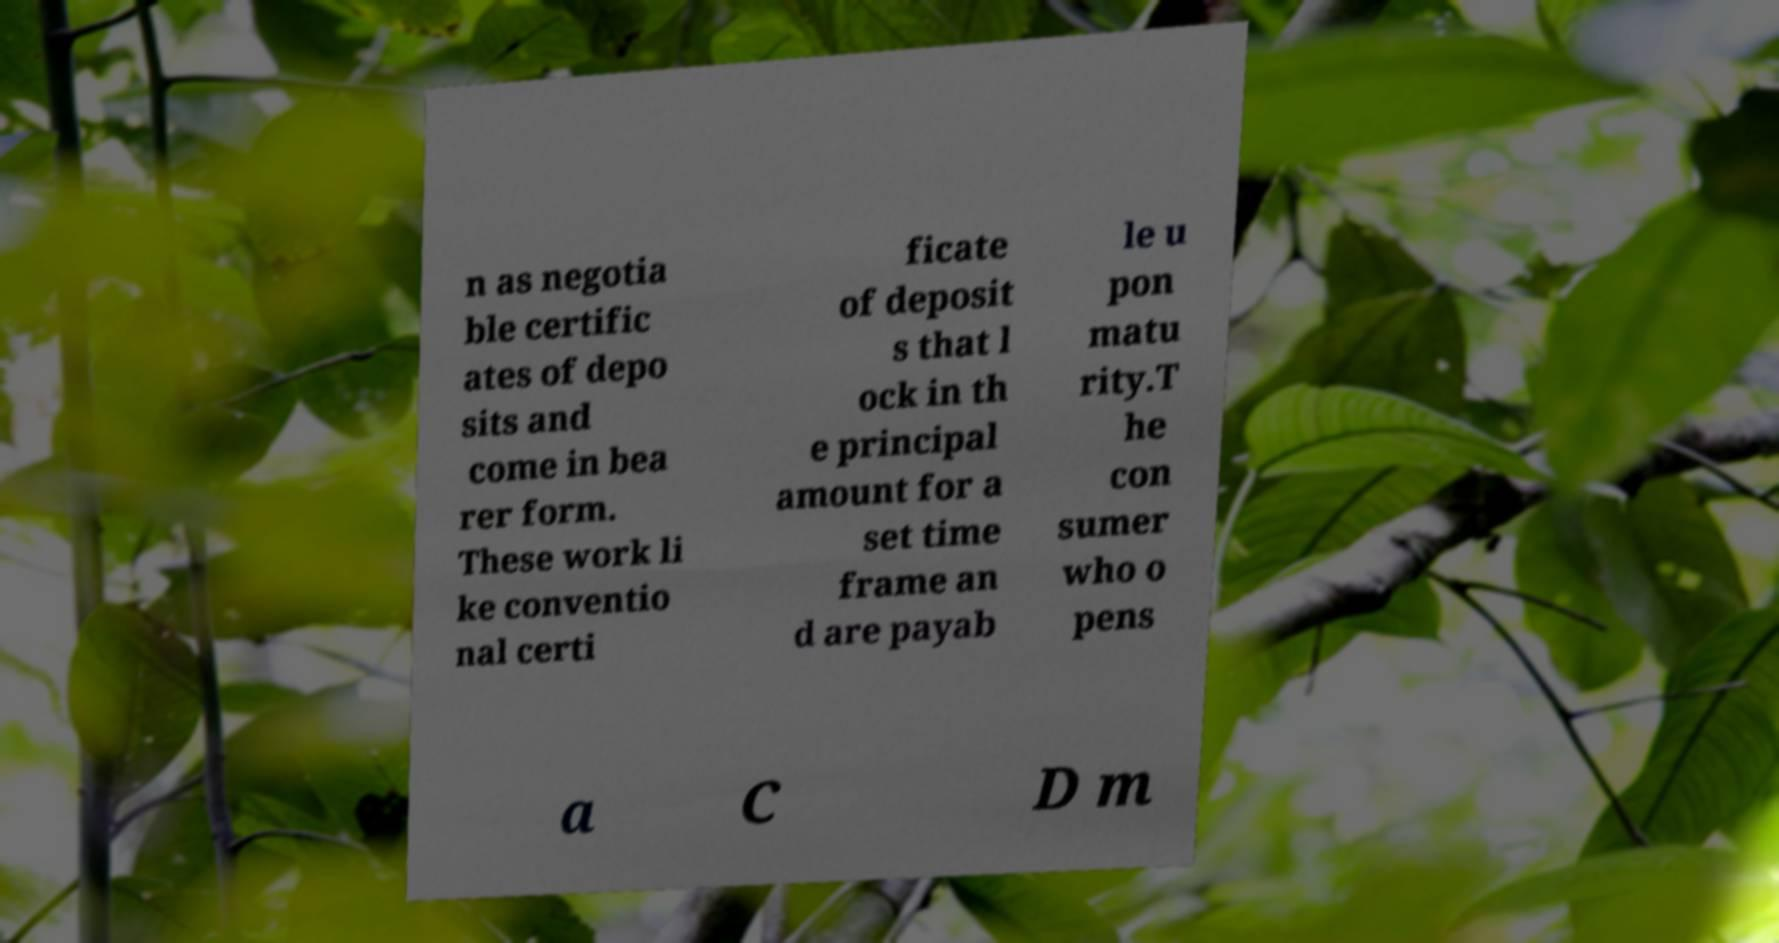Can you read and provide the text displayed in the image?This photo seems to have some interesting text. Can you extract and type it out for me? n as negotia ble certific ates of depo sits and come in bea rer form. These work li ke conventio nal certi ficate of deposit s that l ock in th e principal amount for a set time frame an d are payab le u pon matu rity.T he con sumer who o pens a C D m 